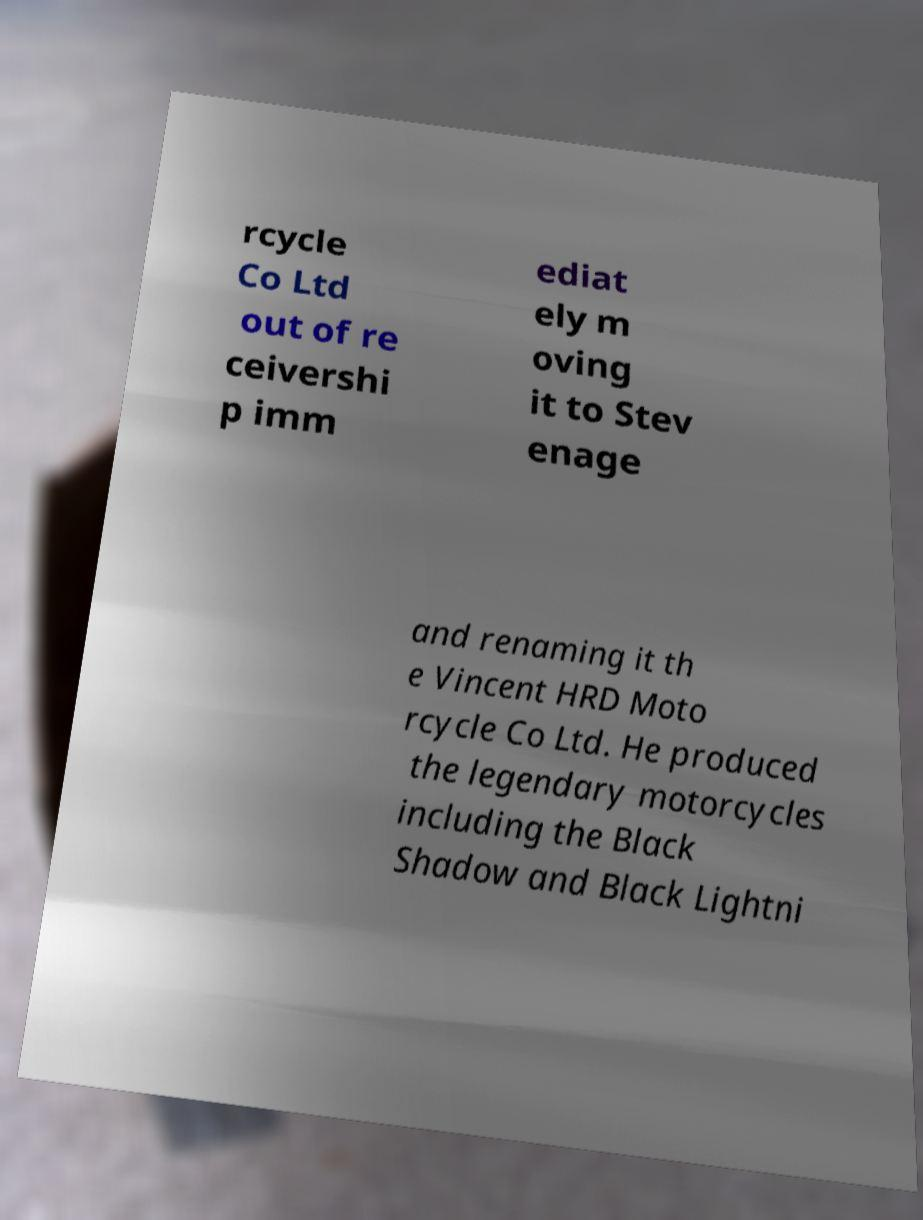Could you extract and type out the text from this image? rcycle Co Ltd out of re ceivershi p imm ediat ely m oving it to Stev enage and renaming it th e Vincent HRD Moto rcycle Co Ltd. He produced the legendary motorcycles including the Black Shadow and Black Lightni 